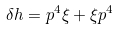Convert formula to latex. <formula><loc_0><loc_0><loc_500><loc_500>\delta h = p ^ { 4 } \xi + \xi p ^ { 4 }</formula> 